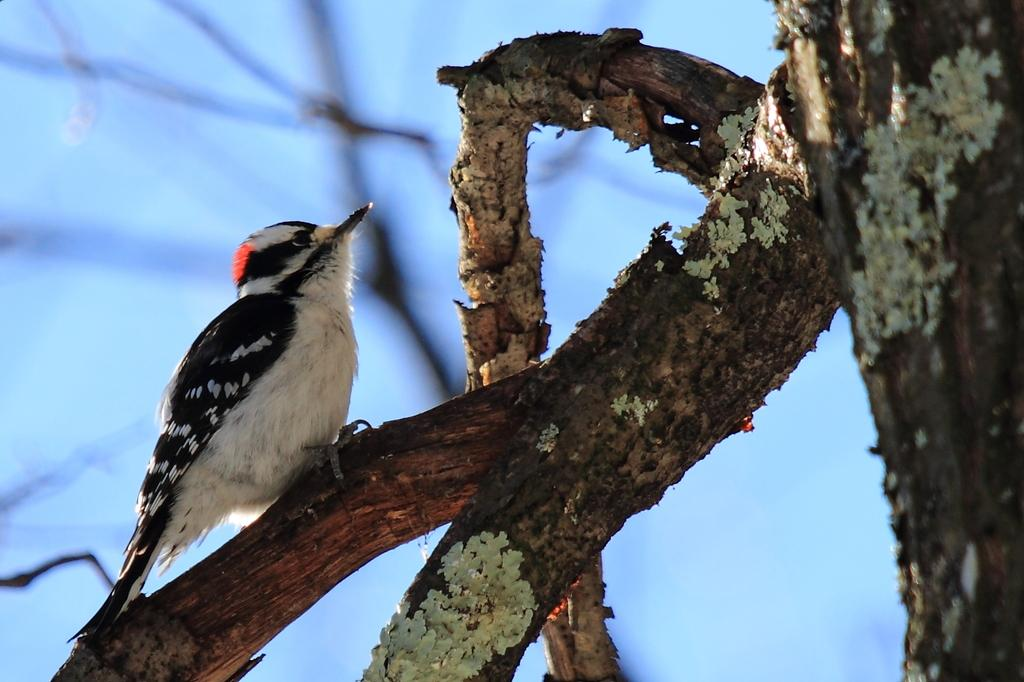What type of animal can be seen in the image? There is a bird in the image. Where is the bird located? The bird is on a tree. What type of stitch is the bird using to sew the leaves together in the image? There is no stitch or sewing activity present in the image; the bird is simply perched on a tree. 